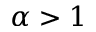Convert formula to latex. <formula><loc_0><loc_0><loc_500><loc_500>\alpha > 1</formula> 